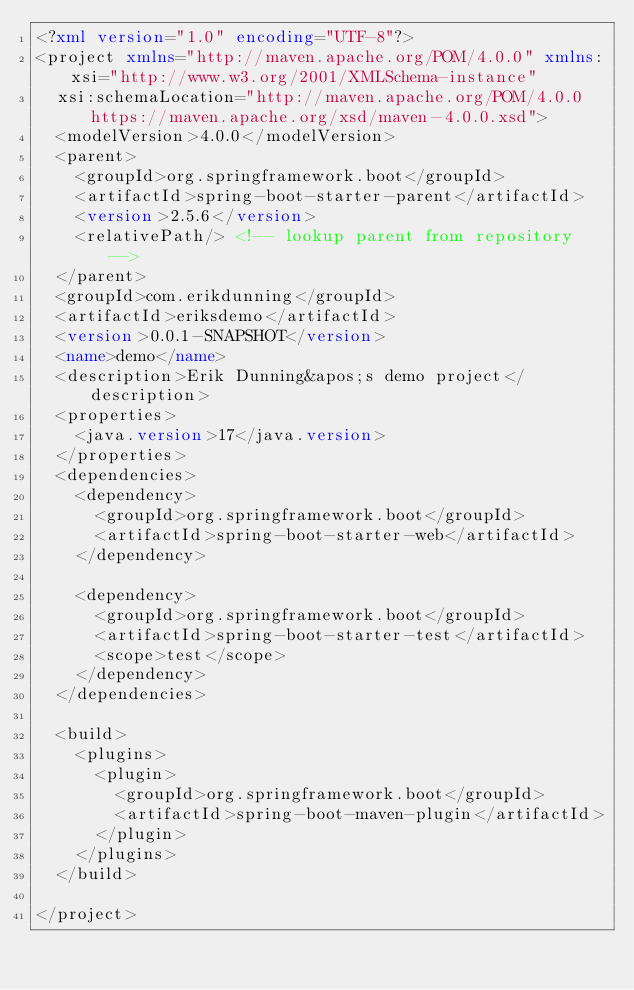Convert code to text. <code><loc_0><loc_0><loc_500><loc_500><_XML_><?xml version="1.0" encoding="UTF-8"?>
<project xmlns="http://maven.apache.org/POM/4.0.0" xmlns:xsi="http://www.w3.org/2001/XMLSchema-instance"
	xsi:schemaLocation="http://maven.apache.org/POM/4.0.0 https://maven.apache.org/xsd/maven-4.0.0.xsd">
	<modelVersion>4.0.0</modelVersion>
	<parent>
		<groupId>org.springframework.boot</groupId>
		<artifactId>spring-boot-starter-parent</artifactId>
		<version>2.5.6</version>
		<relativePath/> <!-- lookup parent from repository -->
	</parent>
	<groupId>com.erikdunning</groupId>
	<artifactId>eriksdemo</artifactId>
	<version>0.0.1-SNAPSHOT</version>
	<name>demo</name>
	<description>Erik Dunning&apos;s demo project</description>
	<properties>
		<java.version>17</java.version>
	</properties>
	<dependencies>
		<dependency>
			<groupId>org.springframework.boot</groupId>
			<artifactId>spring-boot-starter-web</artifactId>
		</dependency>

		<dependency>
			<groupId>org.springframework.boot</groupId>
			<artifactId>spring-boot-starter-test</artifactId>
			<scope>test</scope>
		</dependency>
	</dependencies>

	<build>
		<plugins>
			<plugin>
				<groupId>org.springframework.boot</groupId>
				<artifactId>spring-boot-maven-plugin</artifactId>
			</plugin>
		</plugins>
	</build>

</project>
</code> 